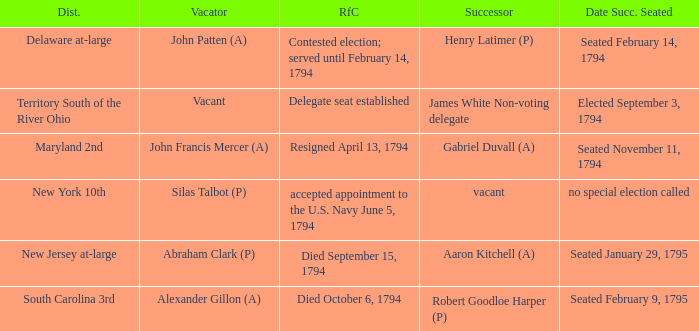Name the date successor seated for contested election; served until february 14, 1794 Seated February 14, 1794. 